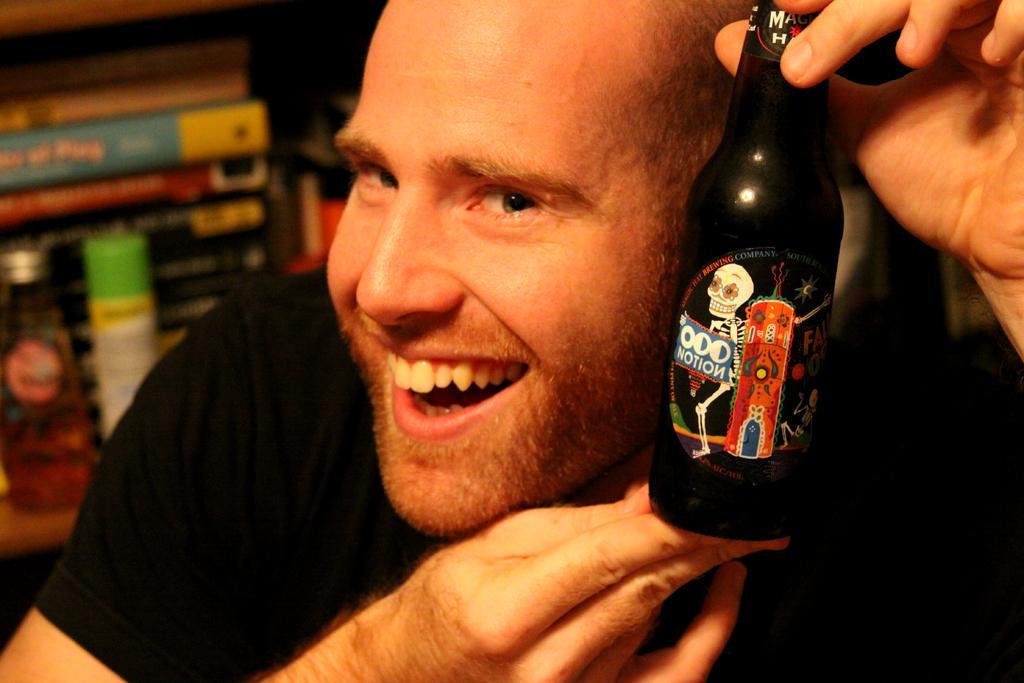Can you describe this image briefly? As we can see in the image there is a man wearing black color t-shirt and a man holding bottle. 